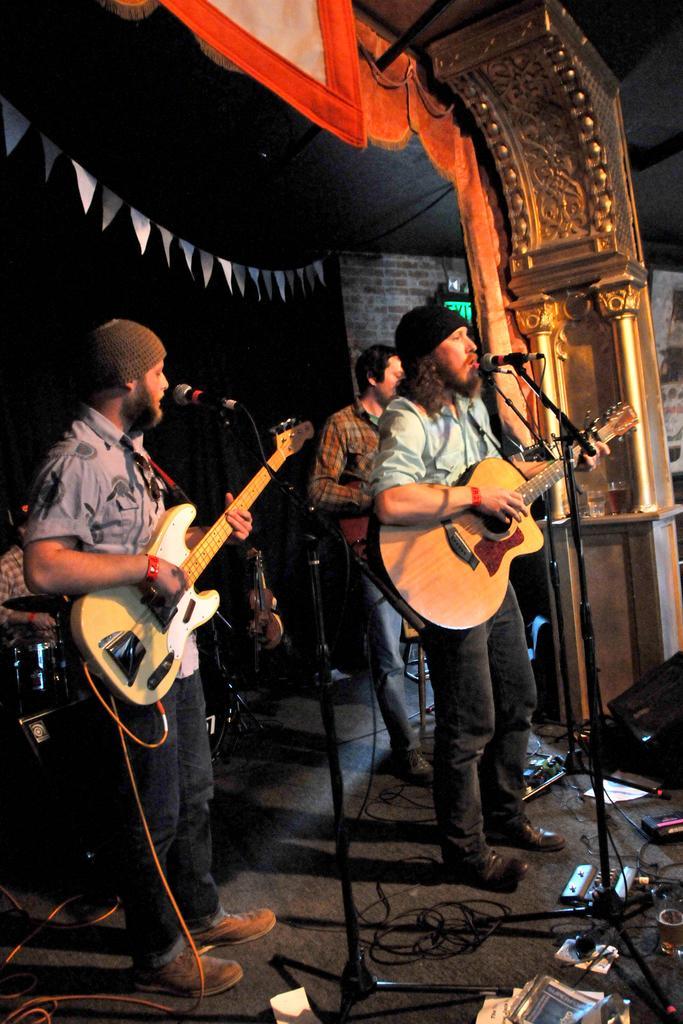In one or two sentences, can you explain what this image depicts? In this image, we can see a platform. Few peoples are playing a musical instrument. 3 three peoples are standing. They are playing a guitar. Here we can see a microphone. And we can see background with a brick wall. We can see some banner here. Here we can see cloth. The left side of the image,the other person is playing a musical instrument. The right side,we can found a pillar. Here we can see few glasses. They are filled with liquid. 